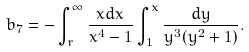<formula> <loc_0><loc_0><loc_500><loc_500>b _ { 7 } = - \int _ { r } ^ { \infty } \frac { x d x } { x ^ { 4 } - 1 } \int _ { 1 } ^ { x } \frac { d y } { y ^ { 3 } ( y ^ { 2 } + 1 ) } .</formula> 